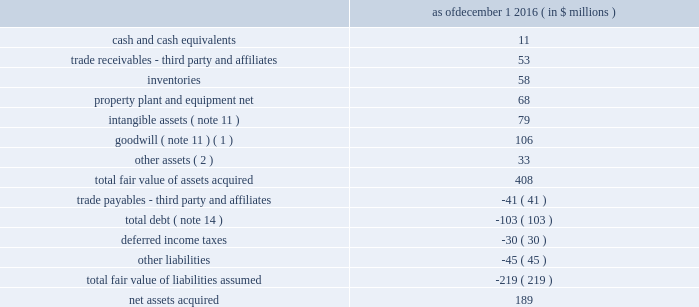Table of contents 4 .
Acquisitions , dispositions and plant closures acquisitions 2022 so.f.ter .
S.p.a .
On december 1 , 2016 , the company acquired 100% ( 100 % ) of the stock of the forli , italy based so.f.ter .
S.p.a .
( "softer" ) , a leading thermoplastic compounder .
The acquisition of softer increases the company's global engineered materials product platforms , extends the operational model , technical and industry solutions capabilities and expands project pipelines .
The acquisition was accounted for as a business combination and the acquired operations are included in the advanced engineered materials segment .
Pro forma financial information since the respective acquisition date has not been provided as the acquisition did not have a material impact on the company's financial information .
The company allocated the purchase price of the acquisition to identifiable assets acquired and liabilities assumed based on their estimated fair values as of the acquisition date .
The excess of the purchase price over the aggregate fair values was recorded as goodwill ( note 2 and note 11 ) .
The company calculated the fair value of the assets acquired using the income , market , or cost approach ( or a combination thereof ) .
Fair values were determined based on level 3 inputs ( note 2 ) including estimated future cash flows , discount rates , royalty rates , growth rates , sales projections , retention rates and terminal values , all of which require significant management judgment and are susceptible to change .
The purchase price allocation is based upon preliminary information and is subject to change if additional information about the facts and circumstances that existed at the acquisition date becomes available .
The final fair value of the net assets acquired may result in adjustments to the assets and liabilities , including goodwill .
However , any subsequent measurement period adjustments are not expected to have a material impact on the company's results of operations .
The preliminary purchase price allocation for the softer acquisition is as follows : december 1 , 2016 ( in $ millions ) .
______________________________ ( 1 ) goodwill consists of expected revenue and operating synergies resulting from the acquisition .
None of the goodwill is deductible for income tax purposes .
( 2 ) includes a $ 23 million indemnity receivable for uncertain tax positions related to the acquisition .
Transaction related costs of $ 3 million were expensed as incurred to selling , general and administrative expenses in the consolidated statements of operations .
The amount of pro forma net earnings ( loss ) of softer included in the company's consolidated statement of operations was approximately 2% ( 2 % ) ( unaudited ) of its consolidated net earnings ( loss ) had the acquisition occurred as of the beginning of 2016 .
The amount of softer net earnings ( loss ) consolidated by the company since the acquisition date was not material. .
If the tax controversy from softer is resolved favorably , what would the gross assets acquired be , in millions? 
Rationale: no payment on the tax indemnity
Computations: (408 - 23)
Answer: 385.0. 